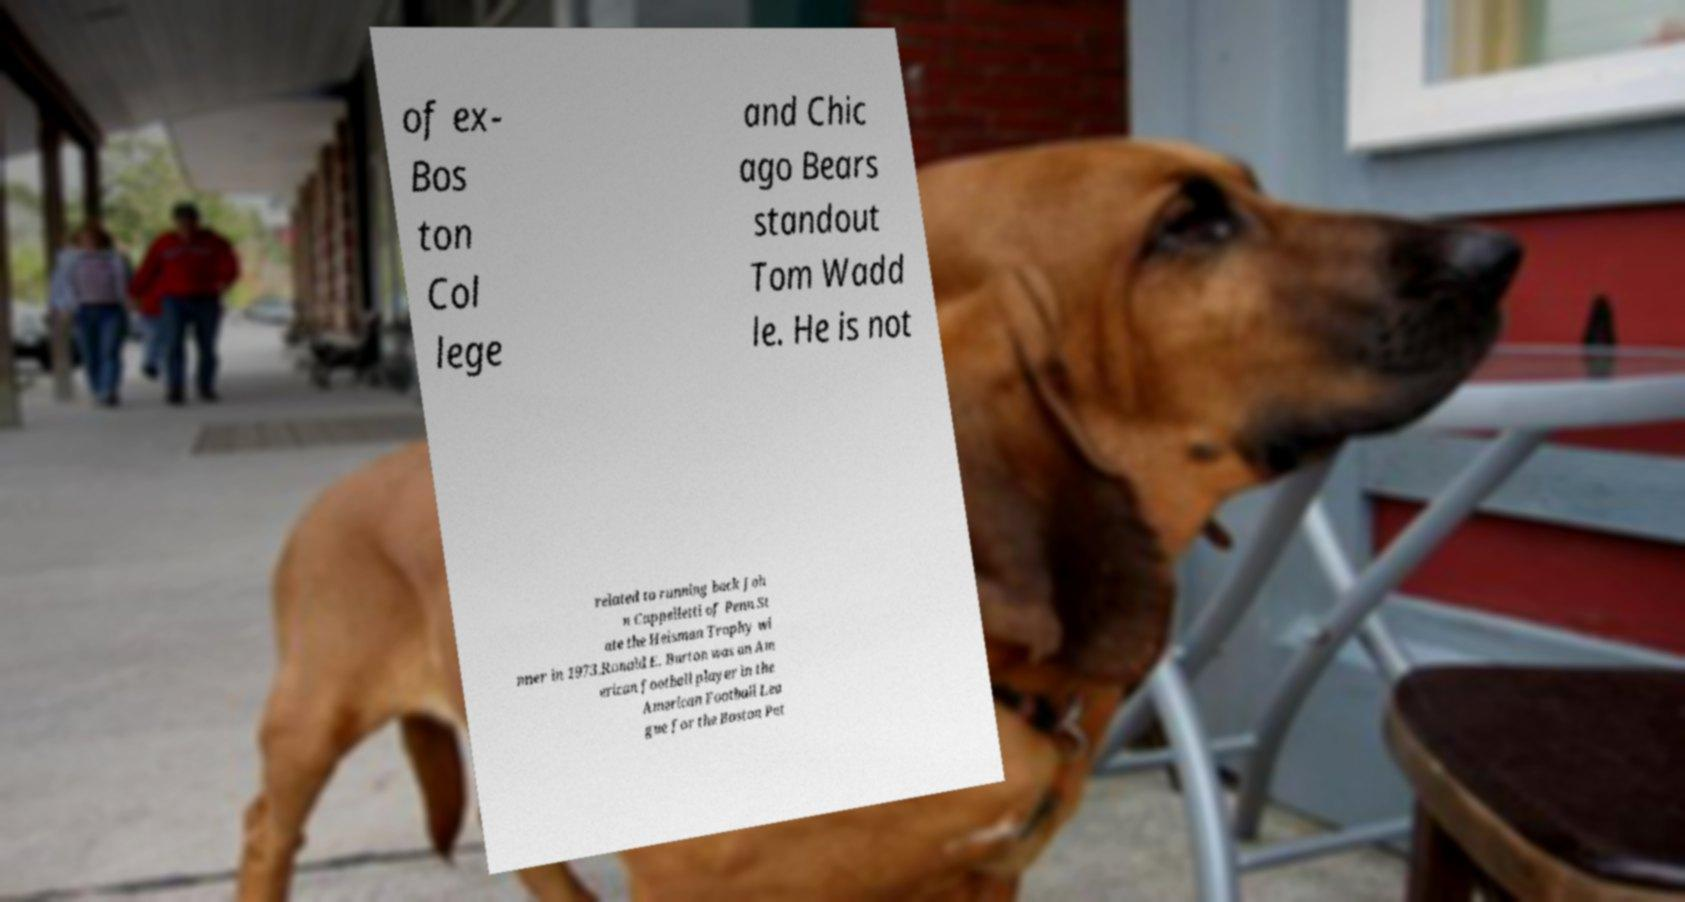Please read and relay the text visible in this image. What does it say? of ex- Bos ton Col lege and Chic ago Bears standout Tom Wadd le. He is not related to running back Joh n Cappelletti of Penn St ate the Heisman Trophy wi nner in 1973.Ronald E. Burton was an Am erican football player in the American Football Lea gue for the Boston Pat 